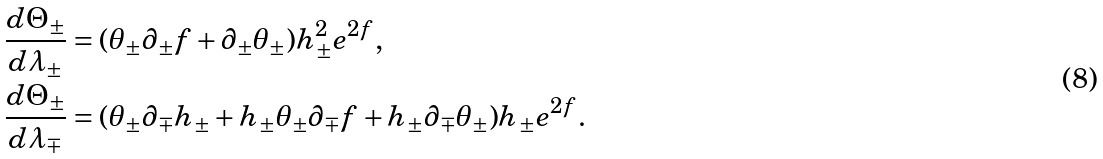Convert formula to latex. <formula><loc_0><loc_0><loc_500><loc_500>\frac { d \Theta _ { \pm } } { d \lambda _ { \pm } } & = ( \theta _ { \pm } \partial _ { \pm } f + \partial _ { \pm } \theta _ { \pm } ) h _ { \pm } ^ { 2 } e ^ { 2 f } , \\ \frac { d \Theta _ { \pm } } { d \lambda _ { \mp } } & = ( \theta _ { \pm } \partial _ { \mp } h _ { \pm } + h _ { \pm } \theta _ { \pm } \partial _ { \mp } f + h _ { \pm } \partial _ { \mp } \theta _ { \pm } ) h _ { \pm } e ^ { 2 f } .</formula> 